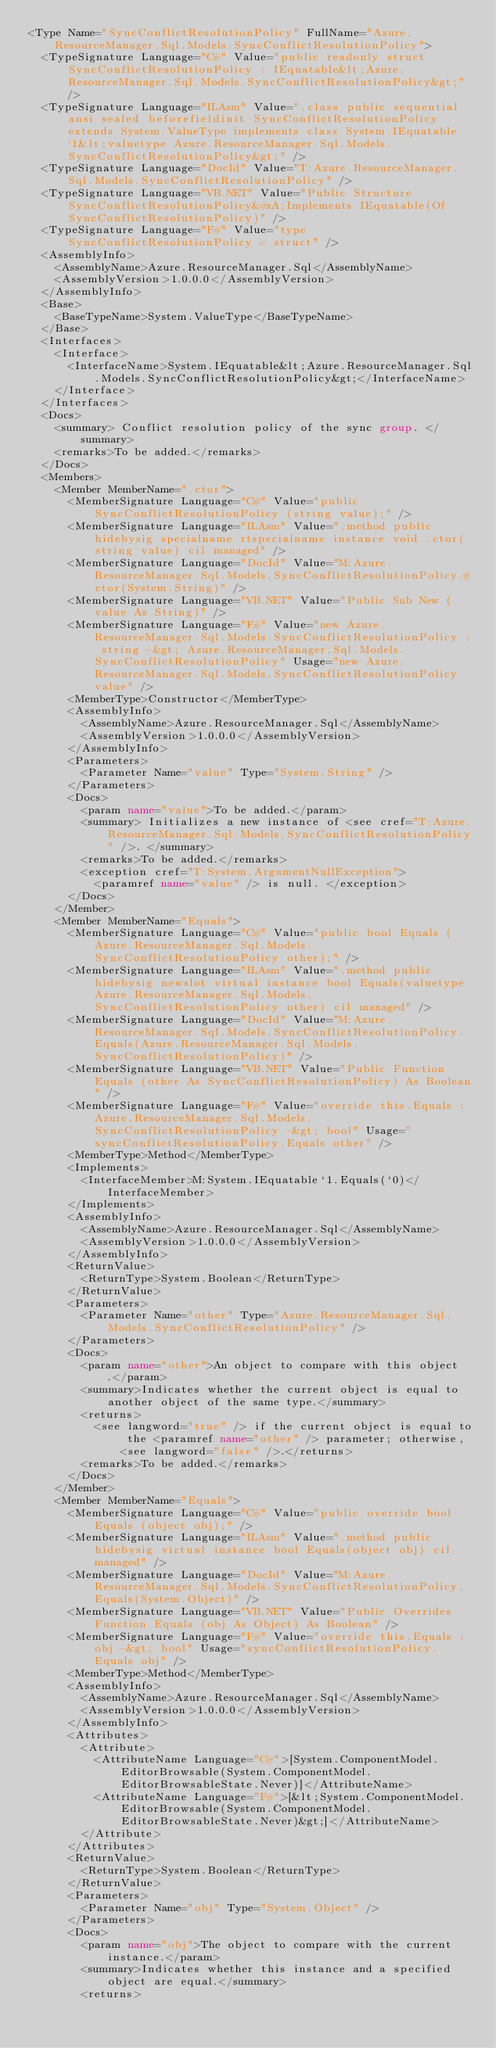Convert code to text. <code><loc_0><loc_0><loc_500><loc_500><_XML_><Type Name="SyncConflictResolutionPolicy" FullName="Azure.ResourceManager.Sql.Models.SyncConflictResolutionPolicy">
  <TypeSignature Language="C#" Value="public readonly struct SyncConflictResolutionPolicy : IEquatable&lt;Azure.ResourceManager.Sql.Models.SyncConflictResolutionPolicy&gt;" />
  <TypeSignature Language="ILAsm" Value=".class public sequential ansi sealed beforefieldinit SyncConflictResolutionPolicy extends System.ValueType implements class System.IEquatable`1&lt;valuetype Azure.ResourceManager.Sql.Models.SyncConflictResolutionPolicy&gt;" />
  <TypeSignature Language="DocId" Value="T:Azure.ResourceManager.Sql.Models.SyncConflictResolutionPolicy" />
  <TypeSignature Language="VB.NET" Value="Public Structure SyncConflictResolutionPolicy&#xA;Implements IEquatable(Of SyncConflictResolutionPolicy)" />
  <TypeSignature Language="F#" Value="type SyncConflictResolutionPolicy = struct" />
  <AssemblyInfo>
    <AssemblyName>Azure.ResourceManager.Sql</AssemblyName>
    <AssemblyVersion>1.0.0.0</AssemblyVersion>
  </AssemblyInfo>
  <Base>
    <BaseTypeName>System.ValueType</BaseTypeName>
  </Base>
  <Interfaces>
    <Interface>
      <InterfaceName>System.IEquatable&lt;Azure.ResourceManager.Sql.Models.SyncConflictResolutionPolicy&gt;</InterfaceName>
    </Interface>
  </Interfaces>
  <Docs>
    <summary> Conflict resolution policy of the sync group. </summary>
    <remarks>To be added.</remarks>
  </Docs>
  <Members>
    <Member MemberName=".ctor">
      <MemberSignature Language="C#" Value="public SyncConflictResolutionPolicy (string value);" />
      <MemberSignature Language="ILAsm" Value=".method public hidebysig specialname rtspecialname instance void .ctor(string value) cil managed" />
      <MemberSignature Language="DocId" Value="M:Azure.ResourceManager.Sql.Models.SyncConflictResolutionPolicy.#ctor(System.String)" />
      <MemberSignature Language="VB.NET" Value="Public Sub New (value As String)" />
      <MemberSignature Language="F#" Value="new Azure.ResourceManager.Sql.Models.SyncConflictResolutionPolicy : string -&gt; Azure.ResourceManager.Sql.Models.SyncConflictResolutionPolicy" Usage="new Azure.ResourceManager.Sql.Models.SyncConflictResolutionPolicy value" />
      <MemberType>Constructor</MemberType>
      <AssemblyInfo>
        <AssemblyName>Azure.ResourceManager.Sql</AssemblyName>
        <AssemblyVersion>1.0.0.0</AssemblyVersion>
      </AssemblyInfo>
      <Parameters>
        <Parameter Name="value" Type="System.String" />
      </Parameters>
      <Docs>
        <param name="value">To be added.</param>
        <summary> Initializes a new instance of <see cref="T:Azure.ResourceManager.Sql.Models.SyncConflictResolutionPolicy" />. </summary>
        <remarks>To be added.</remarks>
        <exception cref="T:System.ArgumentNullException">
          <paramref name="value" /> is null. </exception>
      </Docs>
    </Member>
    <Member MemberName="Equals">
      <MemberSignature Language="C#" Value="public bool Equals (Azure.ResourceManager.Sql.Models.SyncConflictResolutionPolicy other);" />
      <MemberSignature Language="ILAsm" Value=".method public hidebysig newslot virtual instance bool Equals(valuetype Azure.ResourceManager.Sql.Models.SyncConflictResolutionPolicy other) cil managed" />
      <MemberSignature Language="DocId" Value="M:Azure.ResourceManager.Sql.Models.SyncConflictResolutionPolicy.Equals(Azure.ResourceManager.Sql.Models.SyncConflictResolutionPolicy)" />
      <MemberSignature Language="VB.NET" Value="Public Function Equals (other As SyncConflictResolutionPolicy) As Boolean" />
      <MemberSignature Language="F#" Value="override this.Equals : Azure.ResourceManager.Sql.Models.SyncConflictResolutionPolicy -&gt; bool" Usage="syncConflictResolutionPolicy.Equals other" />
      <MemberType>Method</MemberType>
      <Implements>
        <InterfaceMember>M:System.IEquatable`1.Equals(`0)</InterfaceMember>
      </Implements>
      <AssemblyInfo>
        <AssemblyName>Azure.ResourceManager.Sql</AssemblyName>
        <AssemblyVersion>1.0.0.0</AssemblyVersion>
      </AssemblyInfo>
      <ReturnValue>
        <ReturnType>System.Boolean</ReturnType>
      </ReturnValue>
      <Parameters>
        <Parameter Name="other" Type="Azure.ResourceManager.Sql.Models.SyncConflictResolutionPolicy" />
      </Parameters>
      <Docs>
        <param name="other">An object to compare with this object.</param>
        <summary>Indicates whether the current object is equal to another object of the same type.</summary>
        <returns>
          <see langword="true" /> if the current object is equal to the <paramref name="other" /> parameter; otherwise, <see langword="false" />.</returns>
        <remarks>To be added.</remarks>
      </Docs>
    </Member>
    <Member MemberName="Equals">
      <MemberSignature Language="C#" Value="public override bool Equals (object obj);" />
      <MemberSignature Language="ILAsm" Value=".method public hidebysig virtual instance bool Equals(object obj) cil managed" />
      <MemberSignature Language="DocId" Value="M:Azure.ResourceManager.Sql.Models.SyncConflictResolutionPolicy.Equals(System.Object)" />
      <MemberSignature Language="VB.NET" Value="Public Overrides Function Equals (obj As Object) As Boolean" />
      <MemberSignature Language="F#" Value="override this.Equals : obj -&gt; bool" Usage="syncConflictResolutionPolicy.Equals obj" />
      <MemberType>Method</MemberType>
      <AssemblyInfo>
        <AssemblyName>Azure.ResourceManager.Sql</AssemblyName>
        <AssemblyVersion>1.0.0.0</AssemblyVersion>
      </AssemblyInfo>
      <Attributes>
        <Attribute>
          <AttributeName Language="C#">[System.ComponentModel.EditorBrowsable(System.ComponentModel.EditorBrowsableState.Never)]</AttributeName>
          <AttributeName Language="F#">[&lt;System.ComponentModel.EditorBrowsable(System.ComponentModel.EditorBrowsableState.Never)&gt;]</AttributeName>
        </Attribute>
      </Attributes>
      <ReturnValue>
        <ReturnType>System.Boolean</ReturnType>
      </ReturnValue>
      <Parameters>
        <Parameter Name="obj" Type="System.Object" />
      </Parameters>
      <Docs>
        <param name="obj">The object to compare with the current instance.</param>
        <summary>Indicates whether this instance and a specified object are equal.</summary>
        <returns></code> 